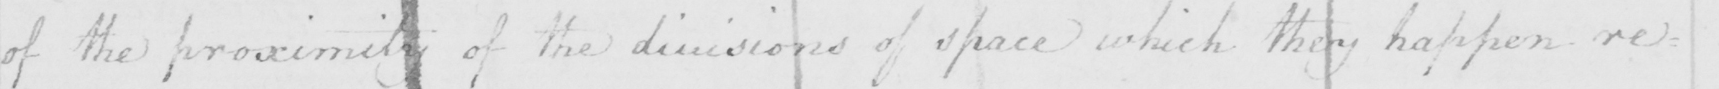Please provide the text content of this handwritten line. of the proximity of the divisions of space which they happen res= 